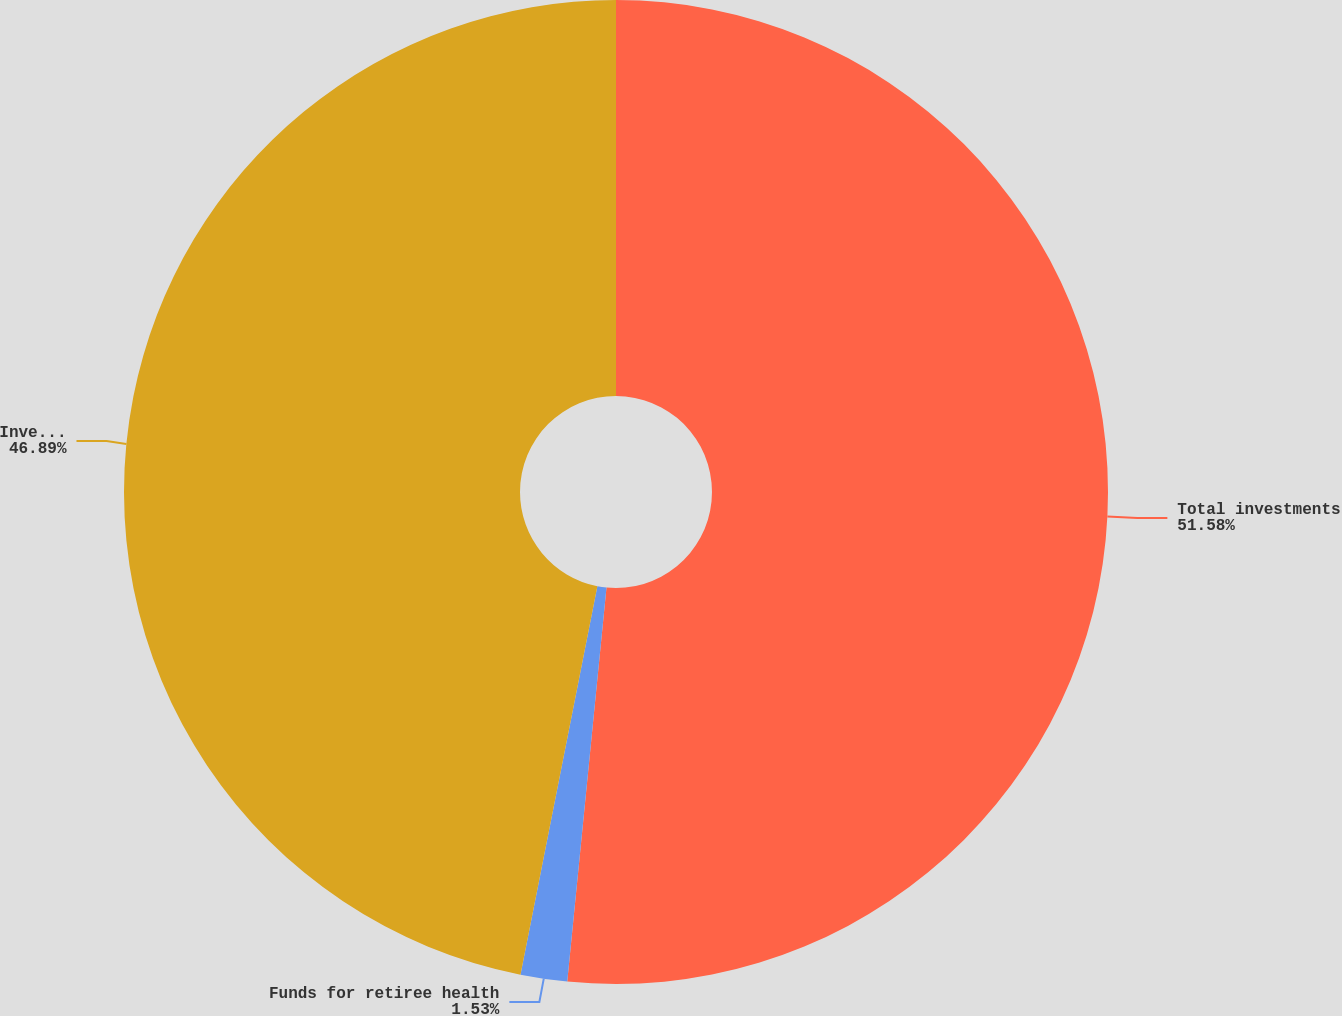<chart> <loc_0><loc_0><loc_500><loc_500><pie_chart><fcel>Total investments<fcel>Funds for retiree health<fcel>Investments(excluding funds<nl><fcel>51.58%<fcel>1.53%<fcel>46.89%<nl></chart> 